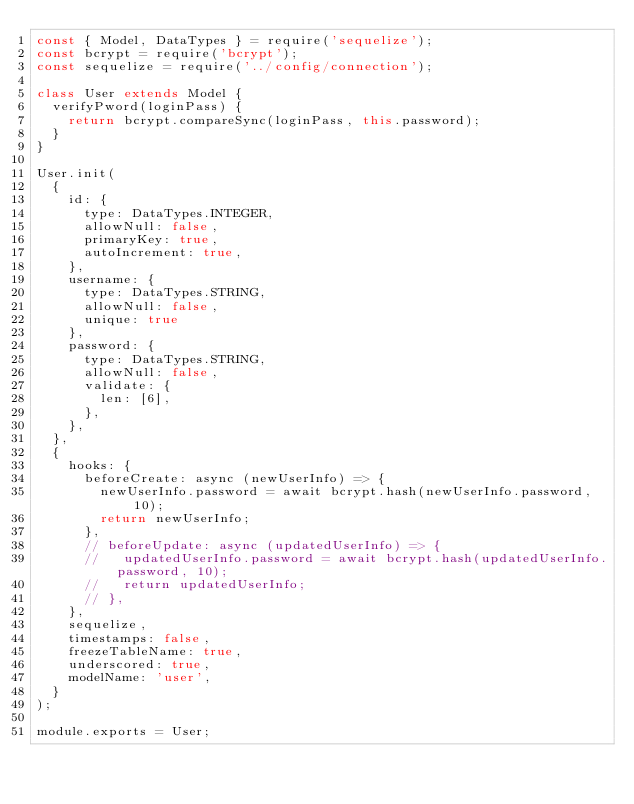<code> <loc_0><loc_0><loc_500><loc_500><_JavaScript_>const { Model, DataTypes } = require('sequelize');
const bcrypt = require('bcrypt');
const sequelize = require('../config/connection');

class User extends Model {
  verifyPword(loginPass) {
    return bcrypt.compareSync(loginPass, this.password);
  }
}

User.init(
  {
    id: {
      type: DataTypes.INTEGER,
      allowNull: false,
      primaryKey: true,
      autoIncrement: true,
    },
    username: {
      type: DataTypes.STRING,
      allowNull: false,
      unique: true
    },
    password: {
      type: DataTypes.STRING,
      allowNull: false,
      validate: {
        len: [6],
      },
    },
  },
  {
    hooks: {
      beforeCreate: async (newUserInfo) => {
        newUserInfo.password = await bcrypt.hash(newUserInfo.password, 10);
        return newUserInfo;
      },
      // beforeUpdate: async (updatedUserInfo) => {
      //   updatedUserInfo.password = await bcrypt.hash(updatedUserInfo.password, 10);
      //   return updatedUserInfo;
      // },
    },
    sequelize,
    timestamps: false,
    freezeTableName: true,
    underscored: true,
    modelName: 'user',
  }
);

module.exports = User;</code> 